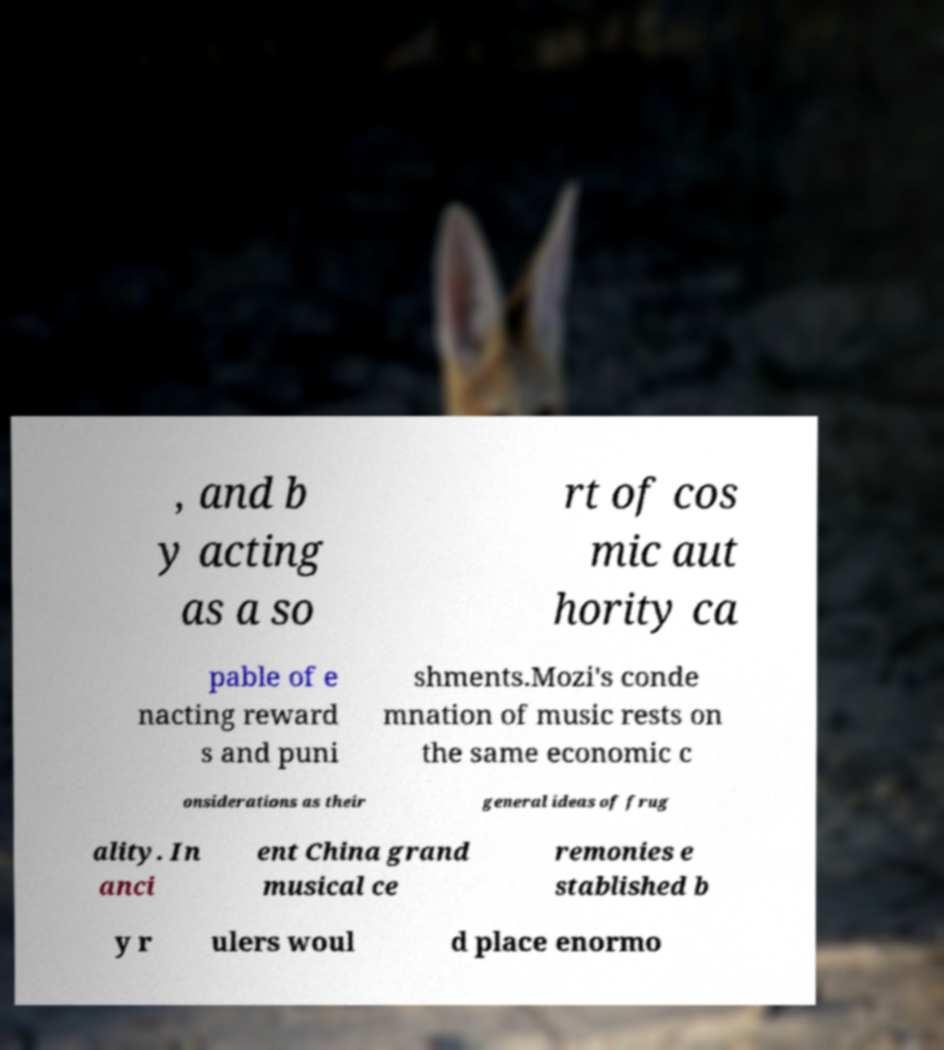Please read and relay the text visible in this image. What does it say? , and b y acting as a so rt of cos mic aut hority ca pable of e nacting reward s and puni shments.Mozi's conde mnation of music rests on the same economic c onsiderations as their general ideas of frug ality. In anci ent China grand musical ce remonies e stablished b y r ulers woul d place enormo 